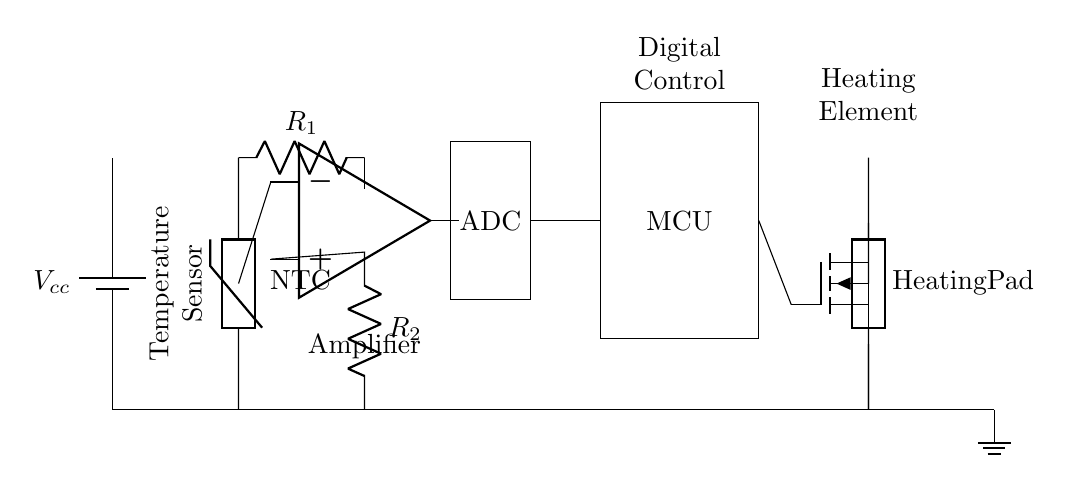What is the main function of the thermistor in this circuit? The thermistor detects temperature changes and adjusts the voltage in response to the ambient temperature. Its main function is to act as a temperature sensor.
Answer: temperature sensor What type of control system is used in this circuit? The circuit employs a microcontroller to read the ADC data and control the MOSFET based on the temperature inputs. This constitutes a digital control system.
Answer: digital control How does the op-amp affect the signal from the thermistor? The op-amp amplifies the voltage signal from the thermistor. It increases the strength of the signal before feeding it to the ADC for digital processing.
Answer: amplifies What component is responsible for switching the power to the heating pad? The MOSFET is responsible for controlling and switching the power delivered to the heating pad based on the signals received from the microcontroller.
Answer: MOSFET Why is a voltage divider needed in this circuit? A voltage divider is used to scale down the voltage from the thermistor to a level suitable for the op-amp input. It ensures that the signal remains within the operating range of the subsequent components.
Answer: scale down What is the purpose of the ADC in this setup? The ADC converts the analog voltage level from the op-amp into a digital signal that can be processed by the microcontroller, facilitating better temperature management.
Answer: conversion 